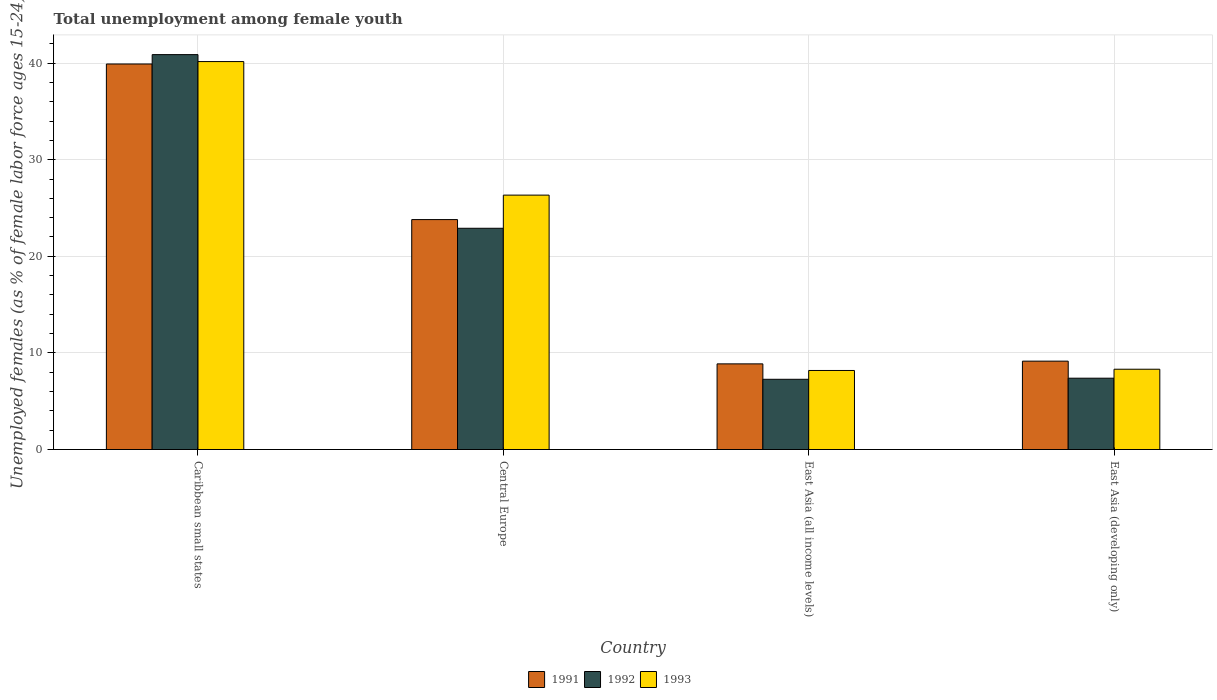Are the number of bars per tick equal to the number of legend labels?
Make the answer very short. Yes. How many bars are there on the 2nd tick from the left?
Provide a short and direct response. 3. What is the label of the 1st group of bars from the left?
Make the answer very short. Caribbean small states. In how many cases, is the number of bars for a given country not equal to the number of legend labels?
Keep it short and to the point. 0. What is the percentage of unemployed females in in 1992 in East Asia (developing only)?
Offer a very short reply. 7.38. Across all countries, what is the maximum percentage of unemployed females in in 1991?
Offer a terse response. 39.91. Across all countries, what is the minimum percentage of unemployed females in in 1993?
Offer a terse response. 8.18. In which country was the percentage of unemployed females in in 1991 maximum?
Your answer should be very brief. Caribbean small states. In which country was the percentage of unemployed females in in 1991 minimum?
Ensure brevity in your answer.  East Asia (all income levels). What is the total percentage of unemployed females in in 1991 in the graph?
Your response must be concise. 81.72. What is the difference between the percentage of unemployed females in in 1992 in East Asia (all income levels) and that in East Asia (developing only)?
Provide a short and direct response. -0.11. What is the difference between the percentage of unemployed females in in 1993 in East Asia (all income levels) and the percentage of unemployed females in in 1991 in Central Europe?
Offer a very short reply. -15.62. What is the average percentage of unemployed females in in 1993 per country?
Provide a short and direct response. 20.75. What is the difference between the percentage of unemployed females in of/in 1991 and percentage of unemployed females in of/in 1993 in Central Europe?
Your answer should be compact. -2.53. What is the ratio of the percentage of unemployed females in in 1993 in Central Europe to that in East Asia (developing only)?
Offer a very short reply. 3.17. Is the percentage of unemployed females in in 1991 in East Asia (all income levels) less than that in East Asia (developing only)?
Your answer should be compact. Yes. What is the difference between the highest and the second highest percentage of unemployed females in in 1991?
Your answer should be very brief. -14.65. What is the difference between the highest and the lowest percentage of unemployed females in in 1992?
Offer a very short reply. 33.61. What does the 2nd bar from the right in East Asia (developing only) represents?
Offer a terse response. 1992. Is it the case that in every country, the sum of the percentage of unemployed females in in 1992 and percentage of unemployed females in in 1993 is greater than the percentage of unemployed females in in 1991?
Give a very brief answer. Yes. How many bars are there?
Provide a short and direct response. 12. Are the values on the major ticks of Y-axis written in scientific E-notation?
Provide a short and direct response. No. Does the graph contain any zero values?
Your answer should be compact. No. Does the graph contain grids?
Give a very brief answer. Yes. Where does the legend appear in the graph?
Ensure brevity in your answer.  Bottom center. What is the title of the graph?
Ensure brevity in your answer.  Total unemployment among female youth. What is the label or title of the X-axis?
Your response must be concise. Country. What is the label or title of the Y-axis?
Make the answer very short. Unemployed females (as % of female labor force ages 15-24). What is the Unemployed females (as % of female labor force ages 15-24) in 1991 in Caribbean small states?
Keep it short and to the point. 39.91. What is the Unemployed females (as % of female labor force ages 15-24) in 1992 in Caribbean small states?
Offer a very short reply. 40.88. What is the Unemployed females (as % of female labor force ages 15-24) in 1993 in Caribbean small states?
Your answer should be compact. 40.16. What is the Unemployed females (as % of female labor force ages 15-24) in 1991 in Central Europe?
Offer a terse response. 23.8. What is the Unemployed females (as % of female labor force ages 15-24) in 1992 in Central Europe?
Offer a terse response. 22.9. What is the Unemployed females (as % of female labor force ages 15-24) in 1993 in Central Europe?
Your response must be concise. 26.33. What is the Unemployed females (as % of female labor force ages 15-24) in 1991 in East Asia (all income levels)?
Offer a terse response. 8.87. What is the Unemployed females (as % of female labor force ages 15-24) in 1992 in East Asia (all income levels)?
Your answer should be very brief. 7.27. What is the Unemployed females (as % of female labor force ages 15-24) in 1993 in East Asia (all income levels)?
Make the answer very short. 8.18. What is the Unemployed females (as % of female labor force ages 15-24) of 1991 in East Asia (developing only)?
Provide a short and direct response. 9.15. What is the Unemployed females (as % of female labor force ages 15-24) in 1992 in East Asia (developing only)?
Provide a short and direct response. 7.38. What is the Unemployed females (as % of female labor force ages 15-24) of 1993 in East Asia (developing only)?
Your response must be concise. 8.31. Across all countries, what is the maximum Unemployed females (as % of female labor force ages 15-24) of 1991?
Give a very brief answer. 39.91. Across all countries, what is the maximum Unemployed females (as % of female labor force ages 15-24) in 1992?
Make the answer very short. 40.88. Across all countries, what is the maximum Unemployed females (as % of female labor force ages 15-24) in 1993?
Offer a very short reply. 40.16. Across all countries, what is the minimum Unemployed females (as % of female labor force ages 15-24) in 1991?
Offer a terse response. 8.87. Across all countries, what is the minimum Unemployed females (as % of female labor force ages 15-24) in 1992?
Provide a succinct answer. 7.27. Across all countries, what is the minimum Unemployed females (as % of female labor force ages 15-24) in 1993?
Offer a terse response. 8.18. What is the total Unemployed females (as % of female labor force ages 15-24) in 1991 in the graph?
Ensure brevity in your answer.  81.72. What is the total Unemployed females (as % of female labor force ages 15-24) in 1992 in the graph?
Provide a short and direct response. 78.43. What is the total Unemployed females (as % of female labor force ages 15-24) of 1993 in the graph?
Keep it short and to the point. 82.99. What is the difference between the Unemployed females (as % of female labor force ages 15-24) in 1991 in Caribbean small states and that in Central Europe?
Your answer should be very brief. 16.11. What is the difference between the Unemployed females (as % of female labor force ages 15-24) of 1992 in Caribbean small states and that in Central Europe?
Provide a succinct answer. 17.98. What is the difference between the Unemployed females (as % of female labor force ages 15-24) in 1993 in Caribbean small states and that in Central Europe?
Give a very brief answer. 13.83. What is the difference between the Unemployed females (as % of female labor force ages 15-24) of 1991 in Caribbean small states and that in East Asia (all income levels)?
Your answer should be compact. 31.04. What is the difference between the Unemployed females (as % of female labor force ages 15-24) in 1992 in Caribbean small states and that in East Asia (all income levels)?
Offer a terse response. 33.61. What is the difference between the Unemployed females (as % of female labor force ages 15-24) of 1993 in Caribbean small states and that in East Asia (all income levels)?
Your answer should be compact. 31.98. What is the difference between the Unemployed females (as % of female labor force ages 15-24) of 1991 in Caribbean small states and that in East Asia (developing only)?
Provide a short and direct response. 30.76. What is the difference between the Unemployed females (as % of female labor force ages 15-24) of 1992 in Caribbean small states and that in East Asia (developing only)?
Provide a succinct answer. 33.5. What is the difference between the Unemployed females (as % of female labor force ages 15-24) in 1993 in Caribbean small states and that in East Asia (developing only)?
Provide a short and direct response. 31.85. What is the difference between the Unemployed females (as % of female labor force ages 15-24) in 1991 in Central Europe and that in East Asia (all income levels)?
Offer a very short reply. 14.94. What is the difference between the Unemployed females (as % of female labor force ages 15-24) of 1992 in Central Europe and that in East Asia (all income levels)?
Offer a terse response. 15.63. What is the difference between the Unemployed females (as % of female labor force ages 15-24) of 1993 in Central Europe and that in East Asia (all income levels)?
Your response must be concise. 18.15. What is the difference between the Unemployed females (as % of female labor force ages 15-24) in 1991 in Central Europe and that in East Asia (developing only)?
Offer a terse response. 14.65. What is the difference between the Unemployed females (as % of female labor force ages 15-24) of 1992 in Central Europe and that in East Asia (developing only)?
Keep it short and to the point. 15.52. What is the difference between the Unemployed females (as % of female labor force ages 15-24) of 1993 in Central Europe and that in East Asia (developing only)?
Provide a succinct answer. 18.02. What is the difference between the Unemployed females (as % of female labor force ages 15-24) of 1991 in East Asia (all income levels) and that in East Asia (developing only)?
Give a very brief answer. -0.28. What is the difference between the Unemployed females (as % of female labor force ages 15-24) of 1992 in East Asia (all income levels) and that in East Asia (developing only)?
Your response must be concise. -0.11. What is the difference between the Unemployed females (as % of female labor force ages 15-24) in 1993 in East Asia (all income levels) and that in East Asia (developing only)?
Ensure brevity in your answer.  -0.13. What is the difference between the Unemployed females (as % of female labor force ages 15-24) in 1991 in Caribbean small states and the Unemployed females (as % of female labor force ages 15-24) in 1992 in Central Europe?
Make the answer very short. 17.01. What is the difference between the Unemployed females (as % of female labor force ages 15-24) of 1991 in Caribbean small states and the Unemployed females (as % of female labor force ages 15-24) of 1993 in Central Europe?
Provide a succinct answer. 13.57. What is the difference between the Unemployed females (as % of female labor force ages 15-24) of 1992 in Caribbean small states and the Unemployed females (as % of female labor force ages 15-24) of 1993 in Central Europe?
Ensure brevity in your answer.  14.54. What is the difference between the Unemployed females (as % of female labor force ages 15-24) in 1991 in Caribbean small states and the Unemployed females (as % of female labor force ages 15-24) in 1992 in East Asia (all income levels)?
Ensure brevity in your answer.  32.64. What is the difference between the Unemployed females (as % of female labor force ages 15-24) of 1991 in Caribbean small states and the Unemployed females (as % of female labor force ages 15-24) of 1993 in East Asia (all income levels)?
Your response must be concise. 31.73. What is the difference between the Unemployed females (as % of female labor force ages 15-24) of 1992 in Caribbean small states and the Unemployed females (as % of female labor force ages 15-24) of 1993 in East Asia (all income levels)?
Your answer should be compact. 32.7. What is the difference between the Unemployed females (as % of female labor force ages 15-24) in 1991 in Caribbean small states and the Unemployed females (as % of female labor force ages 15-24) in 1992 in East Asia (developing only)?
Ensure brevity in your answer.  32.53. What is the difference between the Unemployed females (as % of female labor force ages 15-24) of 1991 in Caribbean small states and the Unemployed females (as % of female labor force ages 15-24) of 1993 in East Asia (developing only)?
Ensure brevity in your answer.  31.6. What is the difference between the Unemployed females (as % of female labor force ages 15-24) in 1992 in Caribbean small states and the Unemployed females (as % of female labor force ages 15-24) in 1993 in East Asia (developing only)?
Provide a succinct answer. 32.57. What is the difference between the Unemployed females (as % of female labor force ages 15-24) of 1991 in Central Europe and the Unemployed females (as % of female labor force ages 15-24) of 1992 in East Asia (all income levels)?
Provide a succinct answer. 16.53. What is the difference between the Unemployed females (as % of female labor force ages 15-24) of 1991 in Central Europe and the Unemployed females (as % of female labor force ages 15-24) of 1993 in East Asia (all income levels)?
Ensure brevity in your answer.  15.62. What is the difference between the Unemployed females (as % of female labor force ages 15-24) of 1992 in Central Europe and the Unemployed females (as % of female labor force ages 15-24) of 1993 in East Asia (all income levels)?
Offer a terse response. 14.72. What is the difference between the Unemployed females (as % of female labor force ages 15-24) of 1991 in Central Europe and the Unemployed females (as % of female labor force ages 15-24) of 1992 in East Asia (developing only)?
Your response must be concise. 16.42. What is the difference between the Unemployed females (as % of female labor force ages 15-24) in 1991 in Central Europe and the Unemployed females (as % of female labor force ages 15-24) in 1993 in East Asia (developing only)?
Make the answer very short. 15.49. What is the difference between the Unemployed females (as % of female labor force ages 15-24) in 1992 in Central Europe and the Unemployed females (as % of female labor force ages 15-24) in 1993 in East Asia (developing only)?
Keep it short and to the point. 14.59. What is the difference between the Unemployed females (as % of female labor force ages 15-24) of 1991 in East Asia (all income levels) and the Unemployed females (as % of female labor force ages 15-24) of 1992 in East Asia (developing only)?
Your response must be concise. 1.48. What is the difference between the Unemployed females (as % of female labor force ages 15-24) of 1991 in East Asia (all income levels) and the Unemployed females (as % of female labor force ages 15-24) of 1993 in East Asia (developing only)?
Give a very brief answer. 0.55. What is the difference between the Unemployed females (as % of female labor force ages 15-24) in 1992 in East Asia (all income levels) and the Unemployed females (as % of female labor force ages 15-24) in 1993 in East Asia (developing only)?
Keep it short and to the point. -1.04. What is the average Unemployed females (as % of female labor force ages 15-24) in 1991 per country?
Provide a succinct answer. 20.43. What is the average Unemployed females (as % of female labor force ages 15-24) in 1992 per country?
Your answer should be compact. 19.61. What is the average Unemployed females (as % of female labor force ages 15-24) in 1993 per country?
Provide a short and direct response. 20.75. What is the difference between the Unemployed females (as % of female labor force ages 15-24) of 1991 and Unemployed females (as % of female labor force ages 15-24) of 1992 in Caribbean small states?
Keep it short and to the point. -0.97. What is the difference between the Unemployed females (as % of female labor force ages 15-24) in 1991 and Unemployed females (as % of female labor force ages 15-24) in 1993 in Caribbean small states?
Your response must be concise. -0.25. What is the difference between the Unemployed females (as % of female labor force ages 15-24) of 1992 and Unemployed females (as % of female labor force ages 15-24) of 1993 in Caribbean small states?
Your answer should be compact. 0.72. What is the difference between the Unemployed females (as % of female labor force ages 15-24) of 1991 and Unemployed females (as % of female labor force ages 15-24) of 1992 in Central Europe?
Offer a terse response. 0.9. What is the difference between the Unemployed females (as % of female labor force ages 15-24) in 1991 and Unemployed females (as % of female labor force ages 15-24) in 1993 in Central Europe?
Offer a very short reply. -2.53. What is the difference between the Unemployed females (as % of female labor force ages 15-24) of 1992 and Unemployed females (as % of female labor force ages 15-24) of 1993 in Central Europe?
Provide a succinct answer. -3.43. What is the difference between the Unemployed females (as % of female labor force ages 15-24) in 1991 and Unemployed females (as % of female labor force ages 15-24) in 1992 in East Asia (all income levels)?
Offer a terse response. 1.6. What is the difference between the Unemployed females (as % of female labor force ages 15-24) of 1991 and Unemployed females (as % of female labor force ages 15-24) of 1993 in East Asia (all income levels)?
Your answer should be compact. 0.68. What is the difference between the Unemployed females (as % of female labor force ages 15-24) of 1992 and Unemployed females (as % of female labor force ages 15-24) of 1993 in East Asia (all income levels)?
Your answer should be very brief. -0.91. What is the difference between the Unemployed females (as % of female labor force ages 15-24) in 1991 and Unemployed females (as % of female labor force ages 15-24) in 1992 in East Asia (developing only)?
Your response must be concise. 1.76. What is the difference between the Unemployed females (as % of female labor force ages 15-24) in 1991 and Unemployed females (as % of female labor force ages 15-24) in 1993 in East Asia (developing only)?
Offer a very short reply. 0.84. What is the difference between the Unemployed females (as % of female labor force ages 15-24) of 1992 and Unemployed females (as % of female labor force ages 15-24) of 1993 in East Asia (developing only)?
Offer a terse response. -0.93. What is the ratio of the Unemployed females (as % of female labor force ages 15-24) in 1991 in Caribbean small states to that in Central Europe?
Keep it short and to the point. 1.68. What is the ratio of the Unemployed females (as % of female labor force ages 15-24) of 1992 in Caribbean small states to that in Central Europe?
Offer a very short reply. 1.78. What is the ratio of the Unemployed females (as % of female labor force ages 15-24) of 1993 in Caribbean small states to that in Central Europe?
Your answer should be very brief. 1.52. What is the ratio of the Unemployed females (as % of female labor force ages 15-24) in 1991 in Caribbean small states to that in East Asia (all income levels)?
Offer a very short reply. 4.5. What is the ratio of the Unemployed females (as % of female labor force ages 15-24) of 1992 in Caribbean small states to that in East Asia (all income levels)?
Your answer should be compact. 5.62. What is the ratio of the Unemployed females (as % of female labor force ages 15-24) of 1993 in Caribbean small states to that in East Asia (all income levels)?
Offer a very short reply. 4.91. What is the ratio of the Unemployed females (as % of female labor force ages 15-24) of 1991 in Caribbean small states to that in East Asia (developing only)?
Ensure brevity in your answer.  4.36. What is the ratio of the Unemployed females (as % of female labor force ages 15-24) of 1992 in Caribbean small states to that in East Asia (developing only)?
Provide a succinct answer. 5.54. What is the ratio of the Unemployed females (as % of female labor force ages 15-24) in 1993 in Caribbean small states to that in East Asia (developing only)?
Offer a terse response. 4.83. What is the ratio of the Unemployed females (as % of female labor force ages 15-24) in 1991 in Central Europe to that in East Asia (all income levels)?
Make the answer very short. 2.68. What is the ratio of the Unemployed females (as % of female labor force ages 15-24) of 1992 in Central Europe to that in East Asia (all income levels)?
Make the answer very short. 3.15. What is the ratio of the Unemployed females (as % of female labor force ages 15-24) of 1993 in Central Europe to that in East Asia (all income levels)?
Keep it short and to the point. 3.22. What is the ratio of the Unemployed females (as % of female labor force ages 15-24) of 1991 in Central Europe to that in East Asia (developing only)?
Offer a very short reply. 2.6. What is the ratio of the Unemployed females (as % of female labor force ages 15-24) in 1992 in Central Europe to that in East Asia (developing only)?
Give a very brief answer. 3.1. What is the ratio of the Unemployed females (as % of female labor force ages 15-24) in 1993 in Central Europe to that in East Asia (developing only)?
Your answer should be very brief. 3.17. What is the ratio of the Unemployed females (as % of female labor force ages 15-24) in 1991 in East Asia (all income levels) to that in East Asia (developing only)?
Your answer should be very brief. 0.97. What is the ratio of the Unemployed females (as % of female labor force ages 15-24) of 1992 in East Asia (all income levels) to that in East Asia (developing only)?
Provide a succinct answer. 0.98. What is the ratio of the Unemployed females (as % of female labor force ages 15-24) of 1993 in East Asia (all income levels) to that in East Asia (developing only)?
Your answer should be very brief. 0.98. What is the difference between the highest and the second highest Unemployed females (as % of female labor force ages 15-24) in 1991?
Your answer should be compact. 16.11. What is the difference between the highest and the second highest Unemployed females (as % of female labor force ages 15-24) in 1992?
Ensure brevity in your answer.  17.98. What is the difference between the highest and the second highest Unemployed females (as % of female labor force ages 15-24) in 1993?
Make the answer very short. 13.83. What is the difference between the highest and the lowest Unemployed females (as % of female labor force ages 15-24) of 1991?
Offer a very short reply. 31.04. What is the difference between the highest and the lowest Unemployed females (as % of female labor force ages 15-24) in 1992?
Your answer should be compact. 33.61. What is the difference between the highest and the lowest Unemployed females (as % of female labor force ages 15-24) in 1993?
Your answer should be very brief. 31.98. 